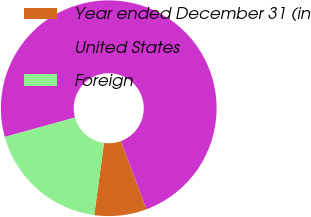<chart> <loc_0><loc_0><loc_500><loc_500><pie_chart><fcel>Year ended December 31 (in<fcel>United States<fcel>Foreign<nl><fcel>7.84%<fcel>73.6%<fcel>18.56%<nl></chart> 